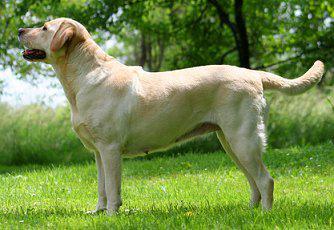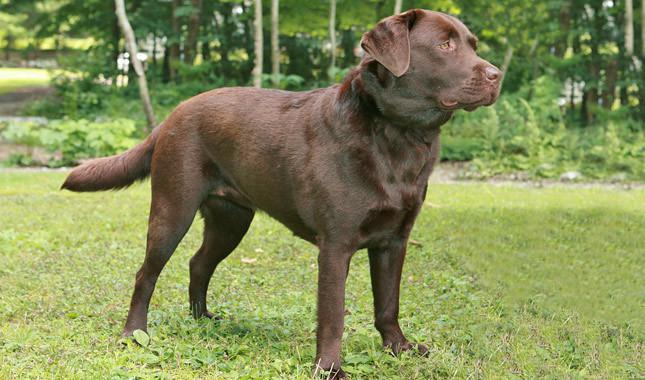The first image is the image on the left, the second image is the image on the right. Given the left and right images, does the statement "Both images contain a dark colored dog." hold true? Answer yes or no. No. The first image is the image on the left, the second image is the image on the right. For the images displayed, is the sentence "Both dogs are facing opposite directions." factually correct? Answer yes or no. Yes. 